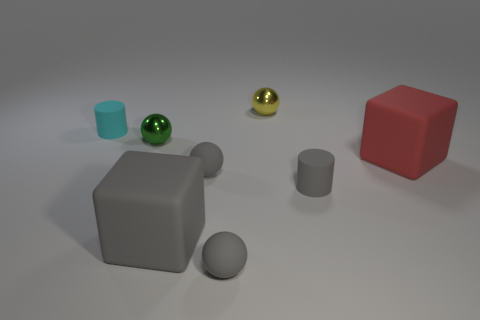Subtract all yellow balls. How many balls are left? 3 Subtract all yellow cylinders. How many red blocks are left? 1 Subtract all small cyan rubber cylinders. Subtract all tiny matte balls. How many objects are left? 5 Add 4 large cubes. How many large cubes are left? 6 Add 5 yellow metallic balls. How many yellow metallic balls exist? 6 Add 2 green spheres. How many objects exist? 10 Subtract all red blocks. How many blocks are left? 1 Subtract 0 blue blocks. How many objects are left? 8 Subtract all cubes. How many objects are left? 6 Subtract 2 cubes. How many cubes are left? 0 